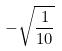Convert formula to latex. <formula><loc_0><loc_0><loc_500><loc_500>- \sqrt { \frac { 1 } { 1 0 } }</formula> 